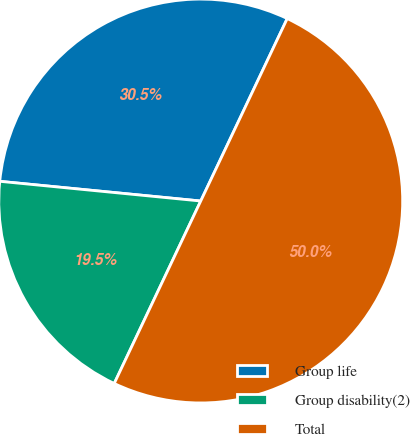Convert chart to OTSL. <chart><loc_0><loc_0><loc_500><loc_500><pie_chart><fcel>Group life<fcel>Group disability(2)<fcel>Total<nl><fcel>30.49%<fcel>19.51%<fcel>50.0%<nl></chart> 